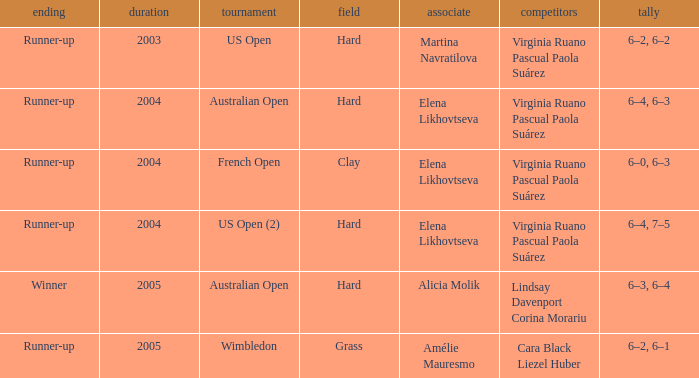When alicia molik is the partner what is the outcome? Winner. 